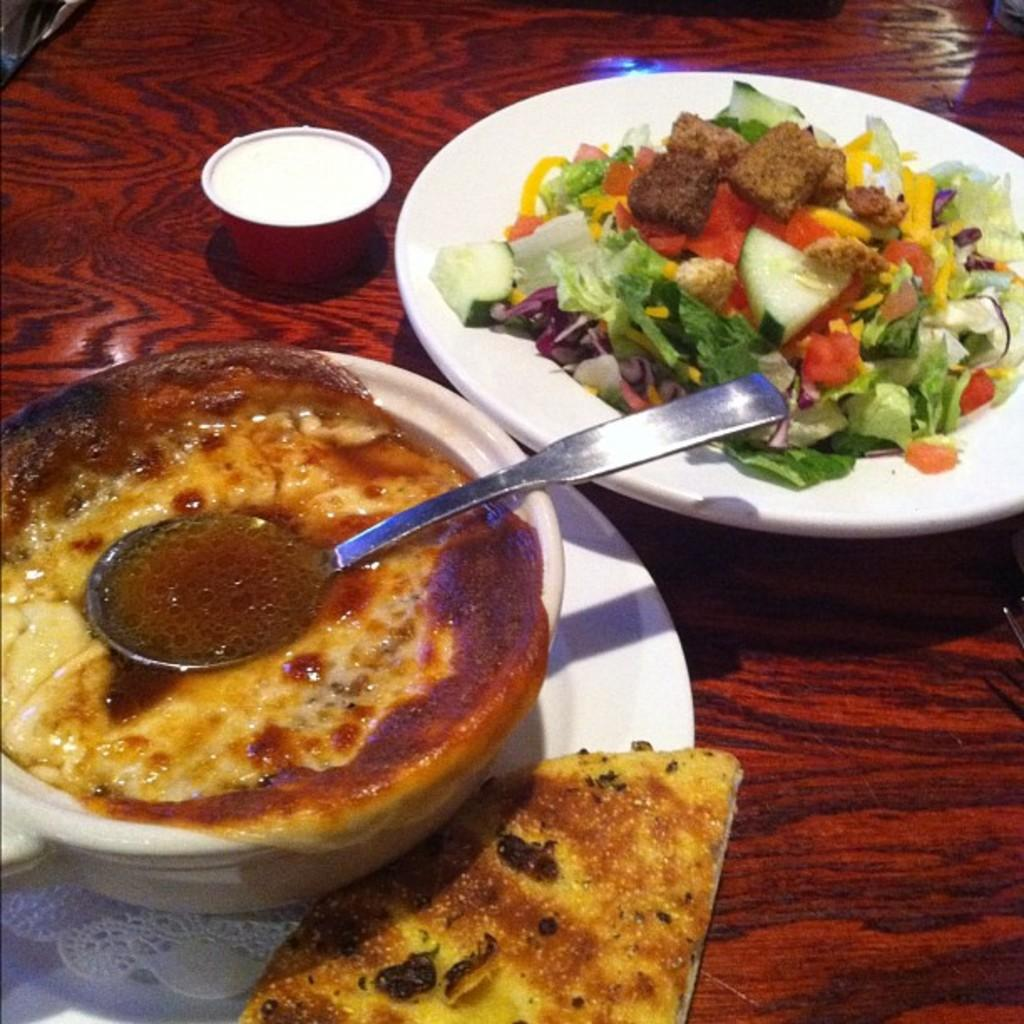What type of food items can be seen in the image? There are food items in a bowl and on a plate in the image. What utensil is present in the image? A spoon is visible in the image. What is the surface on which the food items are placed? The food items are on a wooden surface in the image. What type of mint can be seen growing on the wooden surface in the image? There is no mint visible in the image; it only features food items in a bowl and on a plate, a spoon, and a wooden surface. 